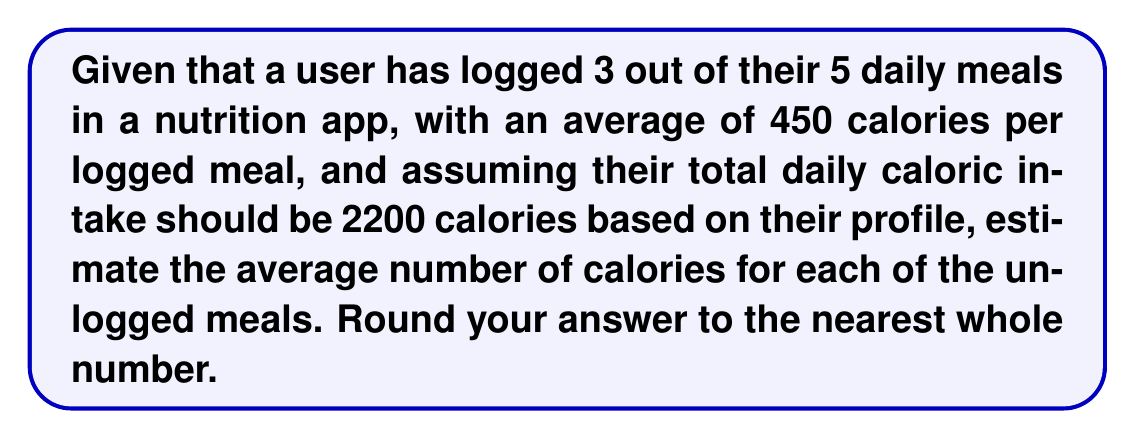Could you help me with this problem? To solve this inverse problem, let's follow these steps:

1. Calculate the total calories from logged meals:
   $3 \times 450 = 1350$ calories

2. Calculate the remaining calories for unlogged meals:
   $2200 - 1350 = 850$ calories

3. Determine the number of unlogged meals:
   $5 - 3 = 2$ meals

4. Calculate the average calories per unlogged meal:
   $$\text{Average calories per unlogged meal} = \frac{\text{Remaining calories}}{\text{Number of unlogged meals}}$$
   $$\text{Average calories per unlogged meal} = \frac{850}{2} = 425$$

5. Round to the nearest whole number:
   $425$ rounds to $425$

Therefore, the estimated average number of calories for each of the unlogged meals is 425 calories.
Answer: 425 calories 